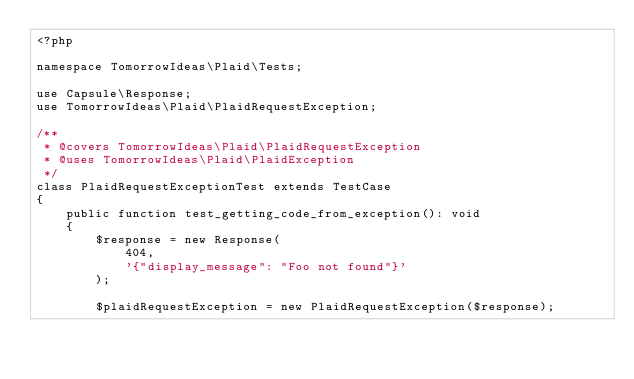Convert code to text. <code><loc_0><loc_0><loc_500><loc_500><_PHP_><?php

namespace TomorrowIdeas\Plaid\Tests;

use Capsule\Response;
use TomorrowIdeas\Plaid\PlaidRequestException;

/**
 * @covers TomorrowIdeas\Plaid\PlaidRequestException
 * @uses TomorrowIdeas\Plaid\PlaidException
 */
class PlaidRequestExceptionTest extends TestCase
{
	public function test_getting_code_from_exception(): void
	{
		$response = new Response(
			404,
			'{"display_message": "Foo not found"}'
		);

		$plaidRequestException = new PlaidRequestException($response);
</code> 